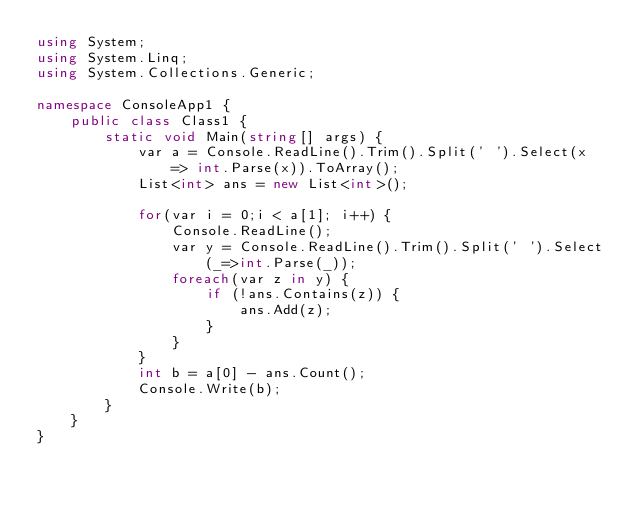<code> <loc_0><loc_0><loc_500><loc_500><_C#_>using System;
using System.Linq;
using System.Collections.Generic;

namespace ConsoleApp1 {
    public class Class1 {
        static void Main(string[] args) {
            var a = Console.ReadLine().Trim().Split(' ').Select(x => int.Parse(x)).ToArray();
            List<int> ans = new List<int>();

            for(var i = 0;i < a[1]; i++) {
                Console.ReadLine();
                var y = Console.ReadLine().Trim().Split(' ').Select(_=>int.Parse(_));
                foreach(var z in y) {
                    if (!ans.Contains(z)) {
                        ans.Add(z);
                    }
                }
            }
            int b = a[0] - ans.Count();
            Console.Write(b);
        }
    }
}</code> 